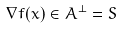<formula> <loc_0><loc_0><loc_500><loc_500>\nabla f ( x ) \in A ^ { \perp } = S</formula> 